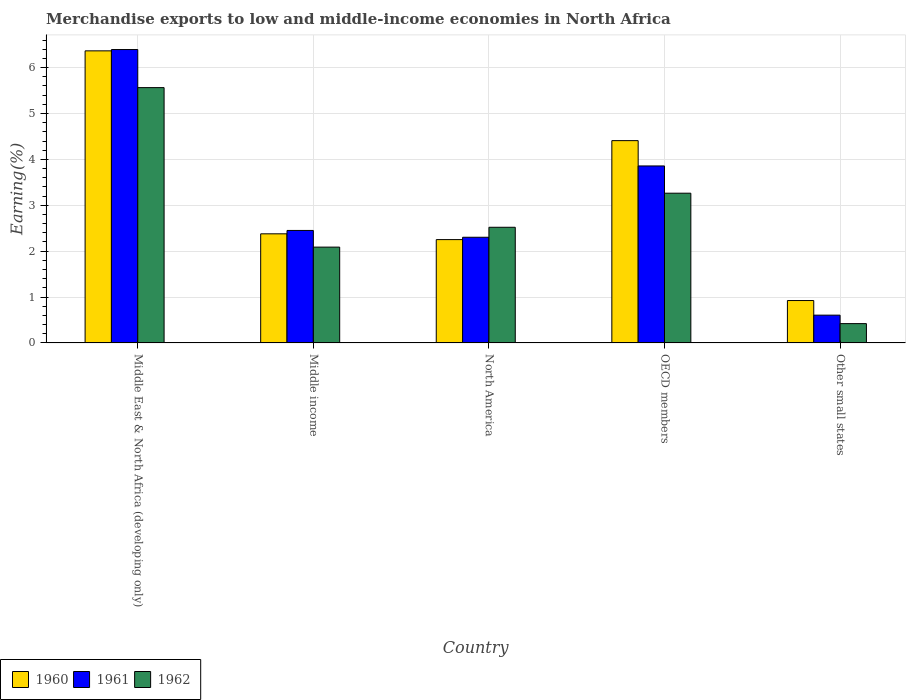Are the number of bars per tick equal to the number of legend labels?
Give a very brief answer. Yes. How many bars are there on the 5th tick from the right?
Your answer should be very brief. 3. In how many cases, is the number of bars for a given country not equal to the number of legend labels?
Offer a terse response. 0. What is the percentage of amount earned from merchandise exports in 1960 in Middle income?
Ensure brevity in your answer.  2.38. Across all countries, what is the maximum percentage of amount earned from merchandise exports in 1962?
Ensure brevity in your answer.  5.56. Across all countries, what is the minimum percentage of amount earned from merchandise exports in 1960?
Provide a short and direct response. 0.92. In which country was the percentage of amount earned from merchandise exports in 1960 maximum?
Your answer should be compact. Middle East & North Africa (developing only). In which country was the percentage of amount earned from merchandise exports in 1962 minimum?
Give a very brief answer. Other small states. What is the total percentage of amount earned from merchandise exports in 1961 in the graph?
Keep it short and to the point. 15.61. What is the difference between the percentage of amount earned from merchandise exports in 1961 in Middle income and that in Other small states?
Your response must be concise. 1.85. What is the difference between the percentage of amount earned from merchandise exports in 1962 in North America and the percentage of amount earned from merchandise exports in 1960 in OECD members?
Keep it short and to the point. -1.89. What is the average percentage of amount earned from merchandise exports in 1961 per country?
Your answer should be very brief. 3.12. What is the difference between the percentage of amount earned from merchandise exports of/in 1960 and percentage of amount earned from merchandise exports of/in 1961 in Middle East & North Africa (developing only)?
Keep it short and to the point. -0.03. In how many countries, is the percentage of amount earned from merchandise exports in 1961 greater than 4.2 %?
Provide a succinct answer. 1. What is the ratio of the percentage of amount earned from merchandise exports in 1961 in Middle East & North Africa (developing only) to that in OECD members?
Your response must be concise. 1.66. Is the percentage of amount earned from merchandise exports in 1962 in Middle East & North Africa (developing only) less than that in Middle income?
Offer a very short reply. No. Is the difference between the percentage of amount earned from merchandise exports in 1960 in North America and Other small states greater than the difference between the percentage of amount earned from merchandise exports in 1961 in North America and Other small states?
Provide a short and direct response. No. What is the difference between the highest and the second highest percentage of amount earned from merchandise exports in 1960?
Provide a short and direct response. -2.03. What is the difference between the highest and the lowest percentage of amount earned from merchandise exports in 1961?
Provide a short and direct response. 5.79. What does the 3rd bar from the left in North America represents?
Give a very brief answer. 1962. What does the 1st bar from the right in Middle income represents?
Provide a succinct answer. 1962. How many bars are there?
Keep it short and to the point. 15. How many countries are there in the graph?
Keep it short and to the point. 5. What is the difference between two consecutive major ticks on the Y-axis?
Offer a terse response. 1. Does the graph contain any zero values?
Offer a terse response. No. Does the graph contain grids?
Give a very brief answer. Yes. How many legend labels are there?
Offer a terse response. 3. What is the title of the graph?
Keep it short and to the point. Merchandise exports to low and middle-income economies in North Africa. What is the label or title of the Y-axis?
Ensure brevity in your answer.  Earning(%). What is the Earning(%) in 1960 in Middle East & North Africa (developing only)?
Your response must be concise. 6.36. What is the Earning(%) of 1961 in Middle East & North Africa (developing only)?
Make the answer very short. 6.39. What is the Earning(%) in 1962 in Middle East & North Africa (developing only)?
Provide a succinct answer. 5.56. What is the Earning(%) of 1960 in Middle income?
Your answer should be very brief. 2.38. What is the Earning(%) in 1961 in Middle income?
Your response must be concise. 2.45. What is the Earning(%) in 1962 in Middle income?
Keep it short and to the point. 2.09. What is the Earning(%) of 1960 in North America?
Provide a succinct answer. 2.25. What is the Earning(%) in 1961 in North America?
Provide a succinct answer. 2.3. What is the Earning(%) of 1962 in North America?
Your answer should be very brief. 2.52. What is the Earning(%) in 1960 in OECD members?
Provide a succinct answer. 4.41. What is the Earning(%) in 1961 in OECD members?
Ensure brevity in your answer.  3.86. What is the Earning(%) of 1962 in OECD members?
Provide a succinct answer. 3.26. What is the Earning(%) in 1960 in Other small states?
Offer a terse response. 0.92. What is the Earning(%) in 1961 in Other small states?
Give a very brief answer. 0.61. What is the Earning(%) of 1962 in Other small states?
Provide a short and direct response. 0.42. Across all countries, what is the maximum Earning(%) of 1960?
Your response must be concise. 6.36. Across all countries, what is the maximum Earning(%) of 1961?
Offer a very short reply. 6.39. Across all countries, what is the maximum Earning(%) of 1962?
Give a very brief answer. 5.56. Across all countries, what is the minimum Earning(%) in 1960?
Your response must be concise. 0.92. Across all countries, what is the minimum Earning(%) of 1961?
Offer a very short reply. 0.61. Across all countries, what is the minimum Earning(%) of 1962?
Your answer should be very brief. 0.42. What is the total Earning(%) in 1960 in the graph?
Make the answer very short. 16.33. What is the total Earning(%) of 1961 in the graph?
Provide a succinct answer. 15.61. What is the total Earning(%) in 1962 in the graph?
Provide a succinct answer. 13.86. What is the difference between the Earning(%) in 1960 in Middle East & North Africa (developing only) and that in Middle income?
Provide a short and direct response. 3.99. What is the difference between the Earning(%) in 1961 in Middle East & North Africa (developing only) and that in Middle income?
Offer a terse response. 3.94. What is the difference between the Earning(%) in 1962 in Middle East & North Africa (developing only) and that in Middle income?
Your answer should be compact. 3.48. What is the difference between the Earning(%) in 1960 in Middle East & North Africa (developing only) and that in North America?
Your answer should be compact. 4.11. What is the difference between the Earning(%) in 1961 in Middle East & North Africa (developing only) and that in North America?
Your answer should be compact. 4.09. What is the difference between the Earning(%) in 1962 in Middle East & North Africa (developing only) and that in North America?
Ensure brevity in your answer.  3.04. What is the difference between the Earning(%) in 1960 in Middle East & North Africa (developing only) and that in OECD members?
Ensure brevity in your answer.  1.96. What is the difference between the Earning(%) in 1961 in Middle East & North Africa (developing only) and that in OECD members?
Provide a succinct answer. 2.54. What is the difference between the Earning(%) of 1962 in Middle East & North Africa (developing only) and that in OECD members?
Your answer should be compact. 2.3. What is the difference between the Earning(%) of 1960 in Middle East & North Africa (developing only) and that in Other small states?
Your answer should be very brief. 5.44. What is the difference between the Earning(%) of 1961 in Middle East & North Africa (developing only) and that in Other small states?
Provide a succinct answer. 5.79. What is the difference between the Earning(%) in 1962 in Middle East & North Africa (developing only) and that in Other small states?
Your answer should be compact. 5.14. What is the difference between the Earning(%) of 1960 in Middle income and that in North America?
Offer a very short reply. 0.13. What is the difference between the Earning(%) of 1961 in Middle income and that in North America?
Provide a short and direct response. 0.15. What is the difference between the Earning(%) of 1962 in Middle income and that in North America?
Make the answer very short. -0.43. What is the difference between the Earning(%) in 1960 in Middle income and that in OECD members?
Offer a very short reply. -2.03. What is the difference between the Earning(%) of 1961 in Middle income and that in OECD members?
Provide a short and direct response. -1.41. What is the difference between the Earning(%) of 1962 in Middle income and that in OECD members?
Make the answer very short. -1.17. What is the difference between the Earning(%) in 1960 in Middle income and that in Other small states?
Offer a very short reply. 1.45. What is the difference between the Earning(%) in 1961 in Middle income and that in Other small states?
Your response must be concise. 1.85. What is the difference between the Earning(%) of 1962 in Middle income and that in Other small states?
Offer a very short reply. 1.67. What is the difference between the Earning(%) of 1960 in North America and that in OECD members?
Make the answer very short. -2.16. What is the difference between the Earning(%) in 1961 in North America and that in OECD members?
Your answer should be compact. -1.55. What is the difference between the Earning(%) in 1962 in North America and that in OECD members?
Your answer should be compact. -0.74. What is the difference between the Earning(%) of 1960 in North America and that in Other small states?
Give a very brief answer. 1.33. What is the difference between the Earning(%) in 1961 in North America and that in Other small states?
Make the answer very short. 1.7. What is the difference between the Earning(%) of 1962 in North America and that in Other small states?
Your answer should be compact. 2.1. What is the difference between the Earning(%) of 1960 in OECD members and that in Other small states?
Provide a succinct answer. 3.48. What is the difference between the Earning(%) in 1961 in OECD members and that in Other small states?
Your answer should be compact. 3.25. What is the difference between the Earning(%) in 1962 in OECD members and that in Other small states?
Give a very brief answer. 2.84. What is the difference between the Earning(%) in 1960 in Middle East & North Africa (developing only) and the Earning(%) in 1961 in Middle income?
Your answer should be very brief. 3.91. What is the difference between the Earning(%) in 1960 in Middle East & North Africa (developing only) and the Earning(%) in 1962 in Middle income?
Your response must be concise. 4.28. What is the difference between the Earning(%) of 1961 in Middle East & North Africa (developing only) and the Earning(%) of 1962 in Middle income?
Your response must be concise. 4.3. What is the difference between the Earning(%) of 1960 in Middle East & North Africa (developing only) and the Earning(%) of 1961 in North America?
Give a very brief answer. 4.06. What is the difference between the Earning(%) in 1960 in Middle East & North Africa (developing only) and the Earning(%) in 1962 in North America?
Ensure brevity in your answer.  3.84. What is the difference between the Earning(%) in 1961 in Middle East & North Africa (developing only) and the Earning(%) in 1962 in North America?
Keep it short and to the point. 3.87. What is the difference between the Earning(%) of 1960 in Middle East & North Africa (developing only) and the Earning(%) of 1961 in OECD members?
Give a very brief answer. 2.51. What is the difference between the Earning(%) in 1960 in Middle East & North Africa (developing only) and the Earning(%) in 1962 in OECD members?
Your response must be concise. 3.1. What is the difference between the Earning(%) in 1961 in Middle East & North Africa (developing only) and the Earning(%) in 1962 in OECD members?
Keep it short and to the point. 3.13. What is the difference between the Earning(%) in 1960 in Middle East & North Africa (developing only) and the Earning(%) in 1961 in Other small states?
Ensure brevity in your answer.  5.76. What is the difference between the Earning(%) of 1960 in Middle East & North Africa (developing only) and the Earning(%) of 1962 in Other small states?
Provide a succinct answer. 5.94. What is the difference between the Earning(%) of 1961 in Middle East & North Africa (developing only) and the Earning(%) of 1962 in Other small states?
Provide a short and direct response. 5.97. What is the difference between the Earning(%) in 1960 in Middle income and the Earning(%) in 1961 in North America?
Make the answer very short. 0.07. What is the difference between the Earning(%) in 1960 in Middle income and the Earning(%) in 1962 in North America?
Keep it short and to the point. -0.14. What is the difference between the Earning(%) of 1961 in Middle income and the Earning(%) of 1962 in North America?
Make the answer very short. -0.07. What is the difference between the Earning(%) of 1960 in Middle income and the Earning(%) of 1961 in OECD members?
Your response must be concise. -1.48. What is the difference between the Earning(%) of 1960 in Middle income and the Earning(%) of 1962 in OECD members?
Your response must be concise. -0.89. What is the difference between the Earning(%) in 1961 in Middle income and the Earning(%) in 1962 in OECD members?
Offer a terse response. -0.81. What is the difference between the Earning(%) of 1960 in Middle income and the Earning(%) of 1961 in Other small states?
Your answer should be compact. 1.77. What is the difference between the Earning(%) in 1960 in Middle income and the Earning(%) in 1962 in Other small states?
Keep it short and to the point. 1.96. What is the difference between the Earning(%) of 1961 in Middle income and the Earning(%) of 1962 in Other small states?
Your response must be concise. 2.03. What is the difference between the Earning(%) in 1960 in North America and the Earning(%) in 1961 in OECD members?
Offer a very short reply. -1.6. What is the difference between the Earning(%) of 1960 in North America and the Earning(%) of 1962 in OECD members?
Ensure brevity in your answer.  -1.01. What is the difference between the Earning(%) of 1961 in North America and the Earning(%) of 1962 in OECD members?
Provide a succinct answer. -0.96. What is the difference between the Earning(%) of 1960 in North America and the Earning(%) of 1961 in Other small states?
Ensure brevity in your answer.  1.65. What is the difference between the Earning(%) of 1960 in North America and the Earning(%) of 1962 in Other small states?
Your answer should be compact. 1.83. What is the difference between the Earning(%) in 1961 in North America and the Earning(%) in 1962 in Other small states?
Provide a short and direct response. 1.88. What is the difference between the Earning(%) in 1960 in OECD members and the Earning(%) in 1961 in Other small states?
Your response must be concise. 3.8. What is the difference between the Earning(%) of 1960 in OECD members and the Earning(%) of 1962 in Other small states?
Your answer should be compact. 3.99. What is the difference between the Earning(%) of 1961 in OECD members and the Earning(%) of 1962 in Other small states?
Keep it short and to the point. 3.44. What is the average Earning(%) in 1960 per country?
Make the answer very short. 3.27. What is the average Earning(%) of 1961 per country?
Make the answer very short. 3.12. What is the average Earning(%) of 1962 per country?
Offer a very short reply. 2.77. What is the difference between the Earning(%) of 1960 and Earning(%) of 1961 in Middle East & North Africa (developing only)?
Provide a succinct answer. -0.03. What is the difference between the Earning(%) of 1960 and Earning(%) of 1962 in Middle East & North Africa (developing only)?
Make the answer very short. 0.8. What is the difference between the Earning(%) of 1961 and Earning(%) of 1962 in Middle East & North Africa (developing only)?
Provide a short and direct response. 0.83. What is the difference between the Earning(%) in 1960 and Earning(%) in 1961 in Middle income?
Your answer should be compact. -0.07. What is the difference between the Earning(%) in 1960 and Earning(%) in 1962 in Middle income?
Keep it short and to the point. 0.29. What is the difference between the Earning(%) of 1961 and Earning(%) of 1962 in Middle income?
Offer a very short reply. 0.36. What is the difference between the Earning(%) of 1960 and Earning(%) of 1961 in North America?
Give a very brief answer. -0.05. What is the difference between the Earning(%) of 1960 and Earning(%) of 1962 in North America?
Give a very brief answer. -0.27. What is the difference between the Earning(%) in 1961 and Earning(%) in 1962 in North America?
Your response must be concise. -0.22. What is the difference between the Earning(%) in 1960 and Earning(%) in 1961 in OECD members?
Keep it short and to the point. 0.55. What is the difference between the Earning(%) of 1960 and Earning(%) of 1962 in OECD members?
Your response must be concise. 1.15. What is the difference between the Earning(%) in 1961 and Earning(%) in 1962 in OECD members?
Your response must be concise. 0.59. What is the difference between the Earning(%) in 1960 and Earning(%) in 1961 in Other small states?
Keep it short and to the point. 0.32. What is the difference between the Earning(%) of 1960 and Earning(%) of 1962 in Other small states?
Make the answer very short. 0.5. What is the difference between the Earning(%) of 1961 and Earning(%) of 1962 in Other small states?
Keep it short and to the point. 0.18. What is the ratio of the Earning(%) of 1960 in Middle East & North Africa (developing only) to that in Middle income?
Make the answer very short. 2.68. What is the ratio of the Earning(%) of 1961 in Middle East & North Africa (developing only) to that in Middle income?
Provide a short and direct response. 2.61. What is the ratio of the Earning(%) in 1962 in Middle East & North Africa (developing only) to that in Middle income?
Provide a succinct answer. 2.66. What is the ratio of the Earning(%) of 1960 in Middle East & North Africa (developing only) to that in North America?
Keep it short and to the point. 2.83. What is the ratio of the Earning(%) in 1961 in Middle East & North Africa (developing only) to that in North America?
Provide a short and direct response. 2.78. What is the ratio of the Earning(%) of 1962 in Middle East & North Africa (developing only) to that in North America?
Your response must be concise. 2.21. What is the ratio of the Earning(%) in 1960 in Middle East & North Africa (developing only) to that in OECD members?
Keep it short and to the point. 1.44. What is the ratio of the Earning(%) in 1961 in Middle East & North Africa (developing only) to that in OECD members?
Keep it short and to the point. 1.66. What is the ratio of the Earning(%) in 1962 in Middle East & North Africa (developing only) to that in OECD members?
Keep it short and to the point. 1.71. What is the ratio of the Earning(%) of 1960 in Middle East & North Africa (developing only) to that in Other small states?
Offer a terse response. 6.89. What is the ratio of the Earning(%) of 1961 in Middle East & North Africa (developing only) to that in Other small states?
Offer a very short reply. 10.56. What is the ratio of the Earning(%) in 1962 in Middle East & North Africa (developing only) to that in Other small states?
Provide a succinct answer. 13.22. What is the ratio of the Earning(%) of 1960 in Middle income to that in North America?
Your response must be concise. 1.06. What is the ratio of the Earning(%) in 1961 in Middle income to that in North America?
Keep it short and to the point. 1.06. What is the ratio of the Earning(%) of 1962 in Middle income to that in North America?
Offer a terse response. 0.83. What is the ratio of the Earning(%) of 1960 in Middle income to that in OECD members?
Provide a succinct answer. 0.54. What is the ratio of the Earning(%) of 1961 in Middle income to that in OECD members?
Provide a short and direct response. 0.64. What is the ratio of the Earning(%) of 1962 in Middle income to that in OECD members?
Keep it short and to the point. 0.64. What is the ratio of the Earning(%) of 1960 in Middle income to that in Other small states?
Your response must be concise. 2.57. What is the ratio of the Earning(%) of 1961 in Middle income to that in Other small states?
Ensure brevity in your answer.  4.05. What is the ratio of the Earning(%) in 1962 in Middle income to that in Other small states?
Your answer should be compact. 4.96. What is the ratio of the Earning(%) of 1960 in North America to that in OECD members?
Keep it short and to the point. 0.51. What is the ratio of the Earning(%) of 1961 in North America to that in OECD members?
Your answer should be compact. 0.6. What is the ratio of the Earning(%) of 1962 in North America to that in OECD members?
Keep it short and to the point. 0.77. What is the ratio of the Earning(%) in 1960 in North America to that in Other small states?
Your answer should be very brief. 2.44. What is the ratio of the Earning(%) in 1961 in North America to that in Other small states?
Your answer should be compact. 3.8. What is the ratio of the Earning(%) of 1962 in North America to that in Other small states?
Ensure brevity in your answer.  5.99. What is the ratio of the Earning(%) of 1960 in OECD members to that in Other small states?
Offer a terse response. 4.77. What is the ratio of the Earning(%) in 1961 in OECD members to that in Other small states?
Offer a terse response. 6.37. What is the ratio of the Earning(%) of 1962 in OECD members to that in Other small states?
Offer a terse response. 7.75. What is the difference between the highest and the second highest Earning(%) in 1960?
Your response must be concise. 1.96. What is the difference between the highest and the second highest Earning(%) of 1961?
Make the answer very short. 2.54. What is the difference between the highest and the second highest Earning(%) of 1962?
Your response must be concise. 2.3. What is the difference between the highest and the lowest Earning(%) in 1960?
Offer a very short reply. 5.44. What is the difference between the highest and the lowest Earning(%) in 1961?
Ensure brevity in your answer.  5.79. What is the difference between the highest and the lowest Earning(%) in 1962?
Your response must be concise. 5.14. 